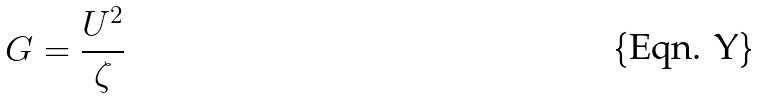Convert formula to latex. <formula><loc_0><loc_0><loc_500><loc_500>G = \frac { U ^ { 2 } } { \zeta }</formula> 